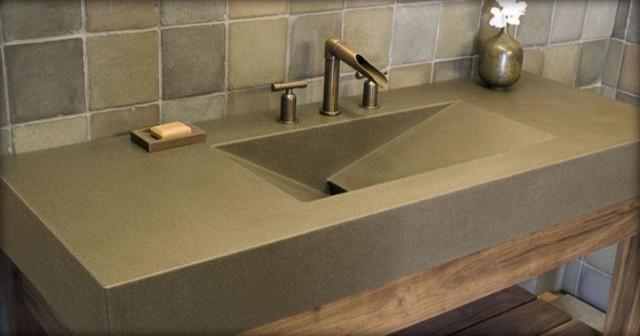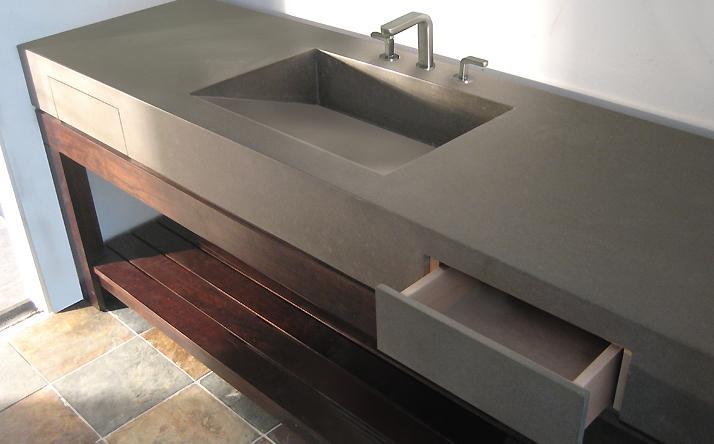The first image is the image on the left, the second image is the image on the right. For the images displayed, is the sentence "In one image the angled view of a wide bathroom sink with squared edges and two sets of faucets shows its inner triangular shape." factually correct? Answer yes or no. No. The first image is the image on the left, the second image is the image on the right. Examine the images to the left and right. Is the description "One vanity features a long gray rectangular trough, with nothing dividing it and with two faucet and spout sets that are not wall-mounted." accurate? Answer yes or no. No. 